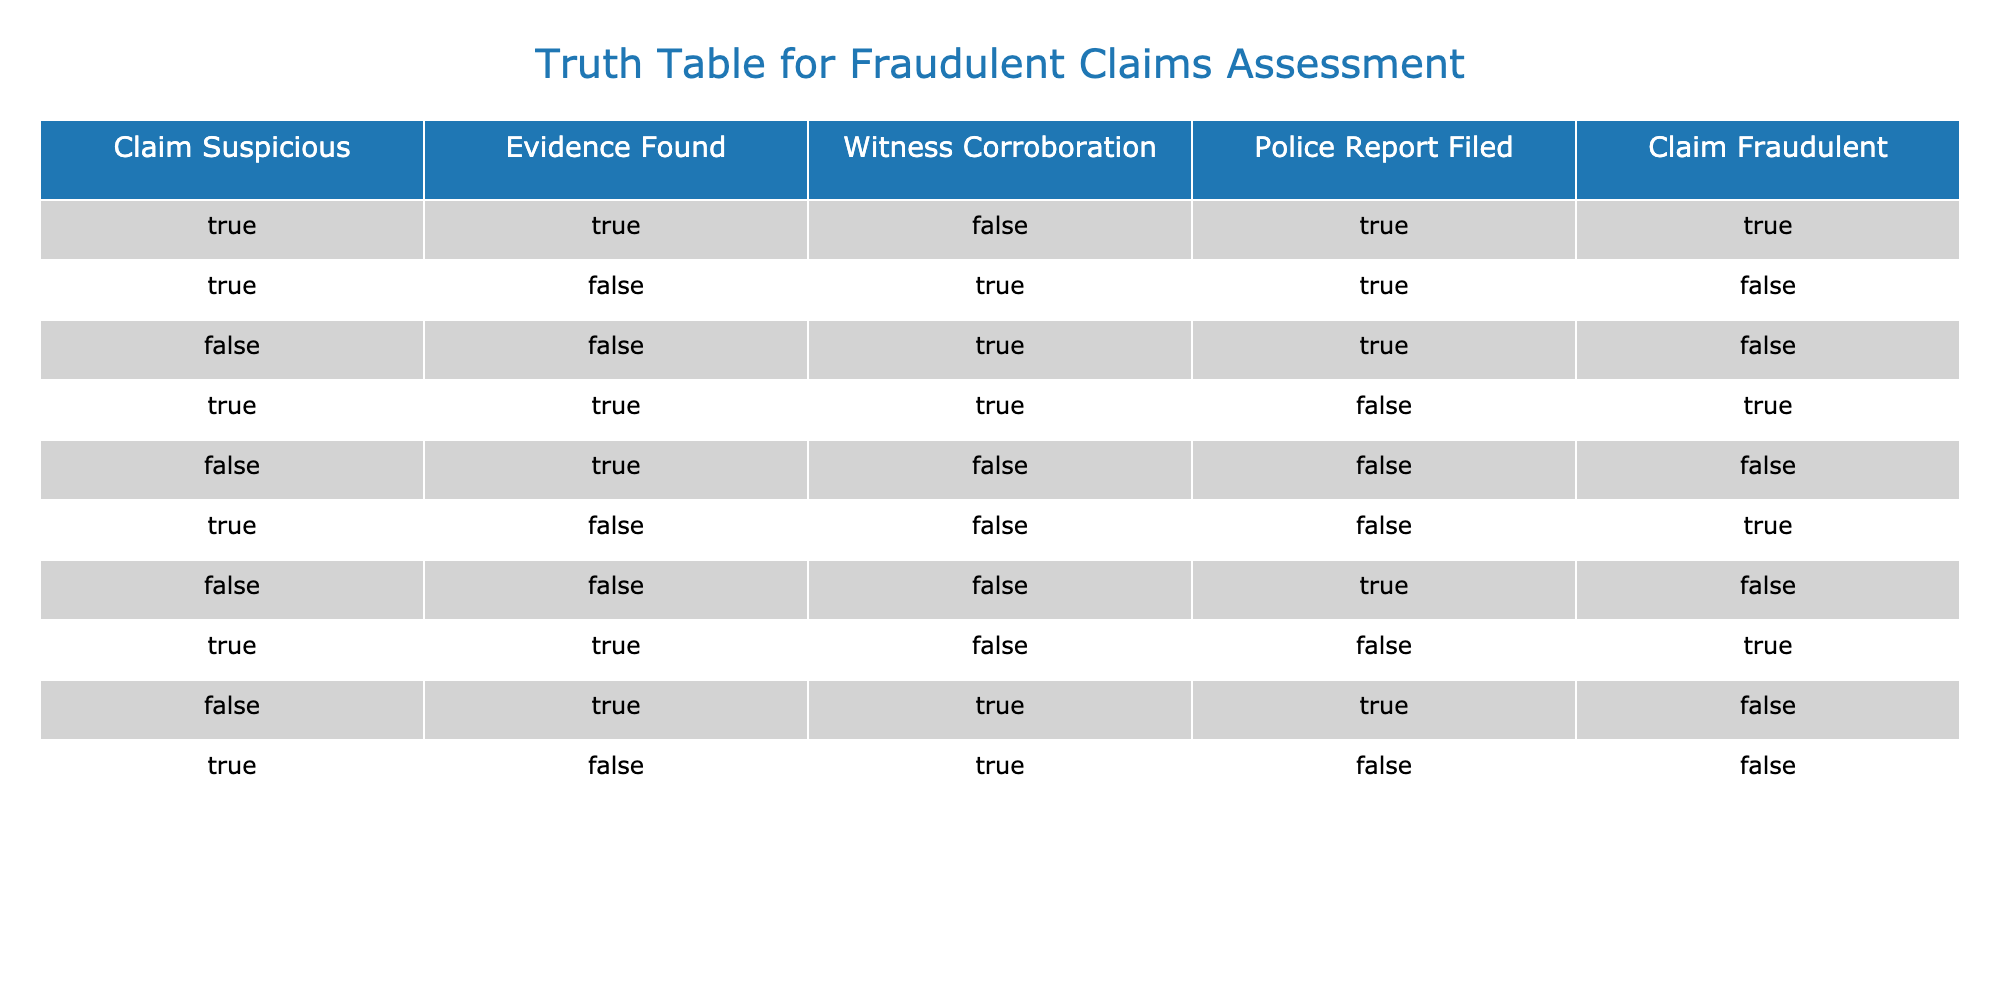What is the number of claims marked as fraudulent? In the table, we can count the number of instances where the "Claim Fraudulent" column has a value of True. There are 5 rows with "Claim Fraudulent" as True.
Answer: 5 How many claims have witness corroboration but are not flagged as fraudulent? We need to look for rows where "Witness Corroboration" is True and "Claim Fraudulent" is False. There are two such rows, specifically, rows 3 and 9.
Answer: 2 Are there any claims where evidence was found but the claim was not fraudulent? To answer this, we look for rows with "Evidence Found" as True and "Claim Fraudulent" as False. Rows 2 and 3 meet this criterion, indicating a total of 2 claims.
Answer: Yes What is the total count of claims that are suspicious and also have evidence found? By checking the table, rows 1, 4, and 7 show "Claim Suspicious" as True and "Evidence Found" as True. We find 3 such claims.
Answer: 3 Is there any claim that is not suspicious but is flagged as fraudulent? We check for rows where "Claim Suspicious" is False and "Claim Fraudulent" is True. Rows do not meet this criterion, hence the answer is no.
Answer: No How many claims have neither evidence found nor police report filed and are also marked as non-fraudulent? Looking at the table, we find rows with "Evidence Found" as False, "Police Report Filed" as False, and "Claim Fraudulent" as False. The only row that fulfills these criteria is row 5.
Answer: 1 What percentage of all claims were flagged as fraudulent? There are a total of 10 claims, and 5 of them are flagged as fraudulent. Therefore, the percentage of fraudulent claims is (5/10) * 100 = 50%.
Answer: 50% How many total claims have received police reports filed? By inspecting the column "Police Report Filed," we identify claims numbered: 1, 2, 3, 7, 8, and 9. This sums to 6 claims with police reports filed.
Answer: 6 What is the relationship between claims flagged as suspicious and the claims found to be fraudulent? To assess this, we can observe rows marked as "Claim Suspicious" alongside "Claim Fraudulent." Out of the 5 claims flagged as suspicious (rows 1, 2, 4, 6, and 10), 3 of them were fraudulent. This indicates a correlation that many suspicious claims can tend to be fraudulent.
Answer: 3 out of 5 